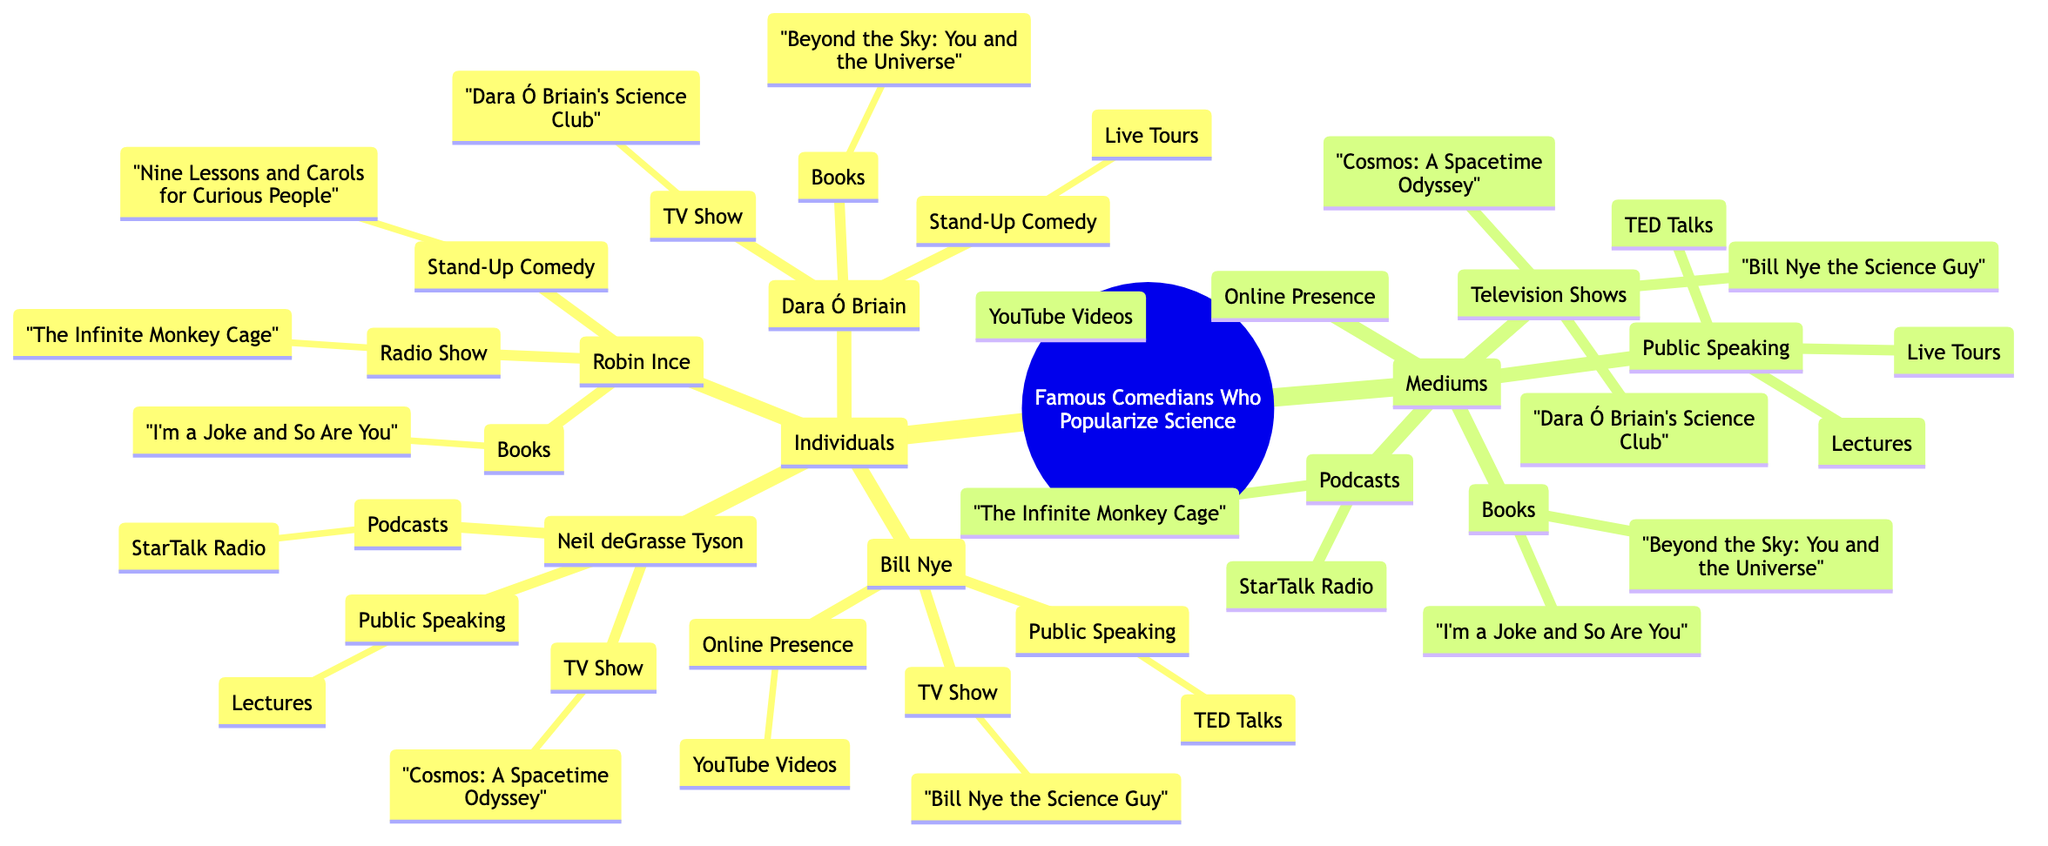What is the title of the mind map? The title is clearly presented at the root node, which states "Famous Comedians Who Popularize Science."
Answer: Famous Comedians Who Popularize Science How many individuals are listed in the mind map? The main branch titled "Individuals" contains four sub-branches, each representing a different comedian.
Answer: 4 Which comedian has a TV show named "Cosmos: A Spacetime Odyssey"? By inspecting the sub-branches under Neil deGrasse Tyson, we can identify that this title is explicitly listed as a TV Show linked to him.
Answer: Neil deGrasse Tyson What is one medium through which Bill Nye shares science? Looking at the sub-branches under Bill Nye, there are multiple mediums mentioned; one example is "YouTube Videos" under the Online Presence sub-branch.
Answer: YouTube Videos Which book is associated with Dara Ó Briain? Navigating the sub-branches under Dara Ó Briain, we find that "Beyond the Sky: You and the Universe" is explicitly connected to him under the Books sub-branch.
Answer: Beyond the Sky: You and the Universe What type of mediums is "StarTalk Radio"? "StarTalk Radio" is found as a sub-branch under the category of "Podcasts," which indicates the medium type.
Answer: Podcasts How many TV shows are listed in total within the mind map? The "Television Shows" sub-branch under the "Mediums" main branch has three distinct entries, thereby contributing to the total count.
Answer: 3 Which comedian is linked to the radio show "The Infinite Monkey Cage"? By checking the sub-branches under Robin Ince, we see that "The Infinite Monkey Cage" is listed under the Radio Show category.
Answer: Robin Ince What is the connection between "Live Tours" and Dara Ó Briain? "Live Tours" is mentioned under the sub-branch "Stand-Up Comedy" linked to Dara Ó Briain, showing his involvement in that medium.
Answer: Stand-Up Comedy 